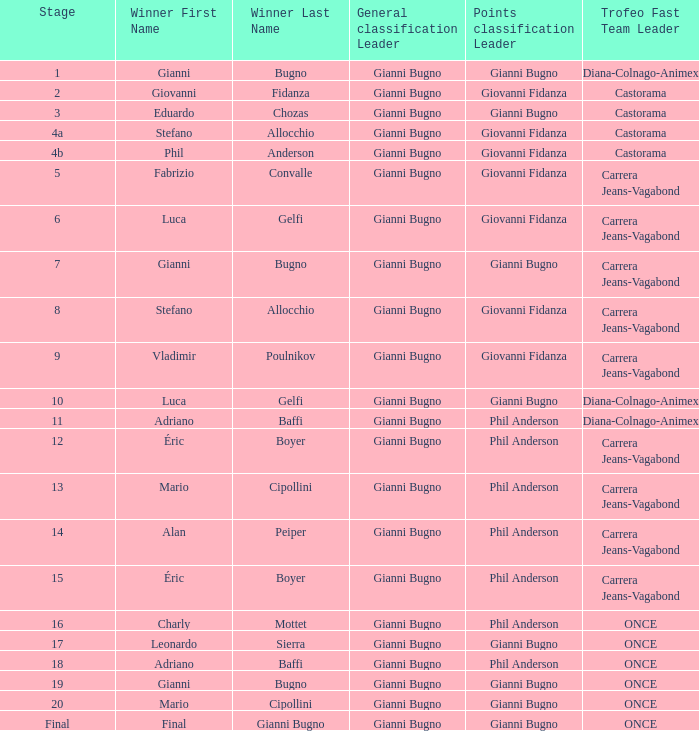Who is the trofeo fast team in stage 10? Diana-Colnago-Animex. 